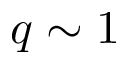<formula> <loc_0><loc_0><loc_500><loc_500>q \sim 1</formula> 